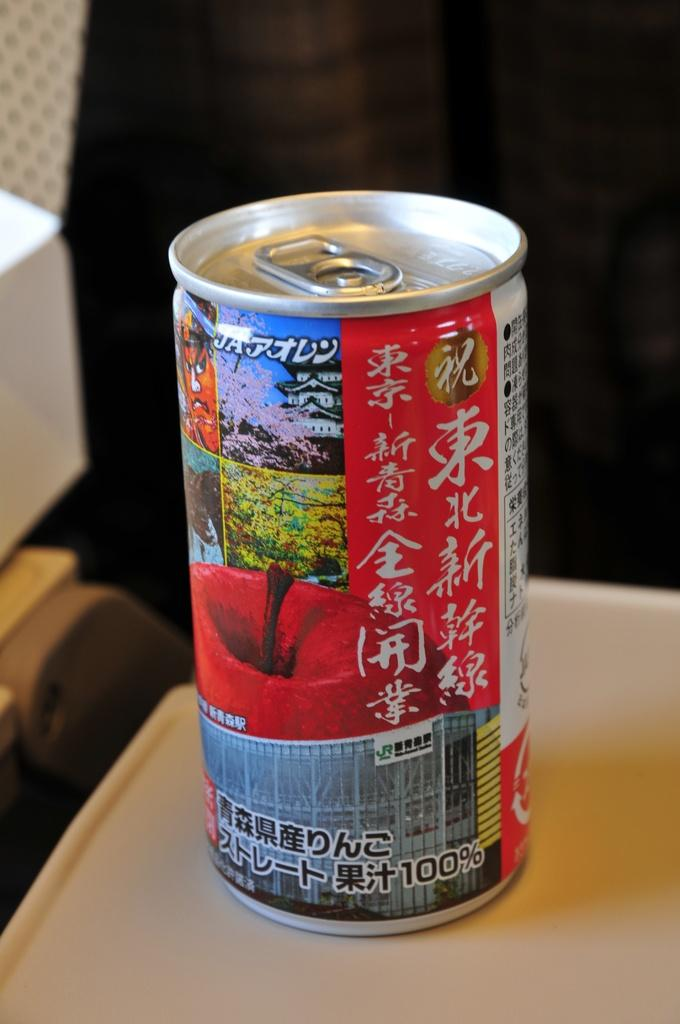What is on the table in the image? There is a drink on the table in the image. What type of pump is visible in the image? There is no pump present in the image; it features a drink on the table. 